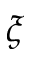Convert formula to latex. <formula><loc_0><loc_0><loc_500><loc_500>\xi</formula> 